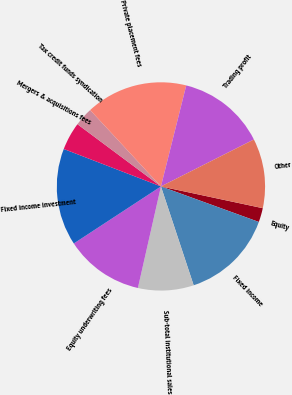<chart> <loc_0><loc_0><loc_500><loc_500><pie_chart><fcel>Equity<fcel>Fixed income<fcel>Sub-total institutional sales<fcel>Equity underwriting fees<fcel>Fixed income investment<fcel>Mergers & acquisitions fees<fcel>Tax credit funds syndication<fcel>Private placement fees<fcel>Trading profit<fcel>Other<nl><fcel>2.19%<fcel>14.37%<fcel>8.64%<fcel>12.22%<fcel>15.08%<fcel>4.34%<fcel>2.91%<fcel>15.8%<fcel>13.65%<fcel>10.79%<nl></chart> 